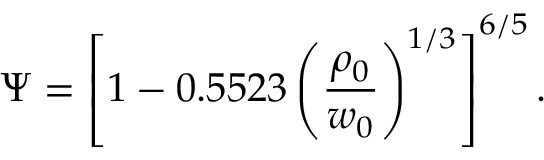Convert formula to latex. <formula><loc_0><loc_0><loc_500><loc_500>\Psi = \left [ 1 - 0 . 5 5 2 3 \left ( \frac { \rho _ { 0 } } { w _ { 0 } } \right ) ^ { 1 / 3 } \right ] ^ { 6 / 5 } .</formula> 